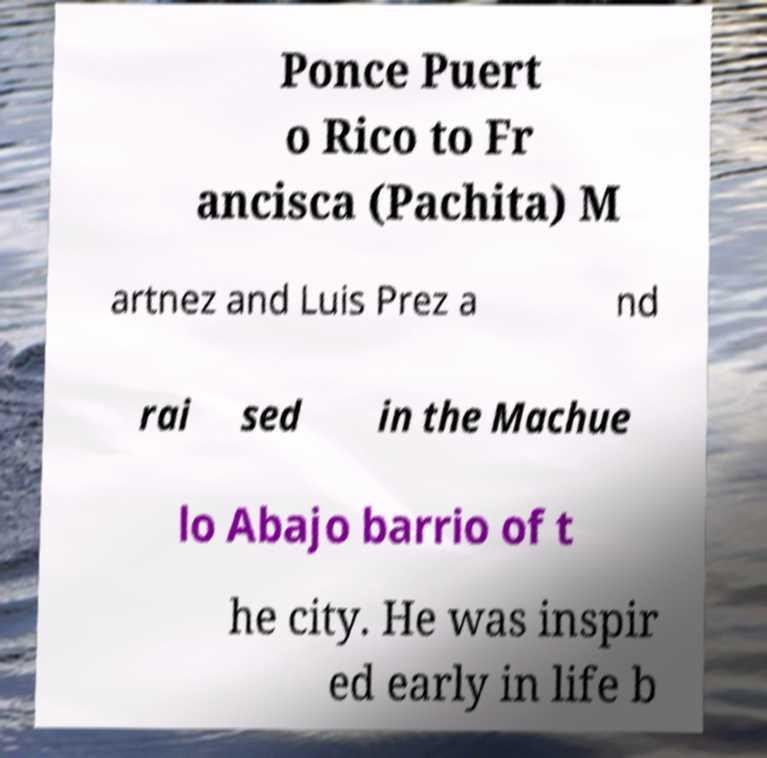There's text embedded in this image that I need extracted. Can you transcribe it verbatim? Ponce Puert o Rico to Fr ancisca (Pachita) M artnez and Luis Prez a nd rai sed in the Machue lo Abajo barrio of t he city. He was inspir ed early in life b 